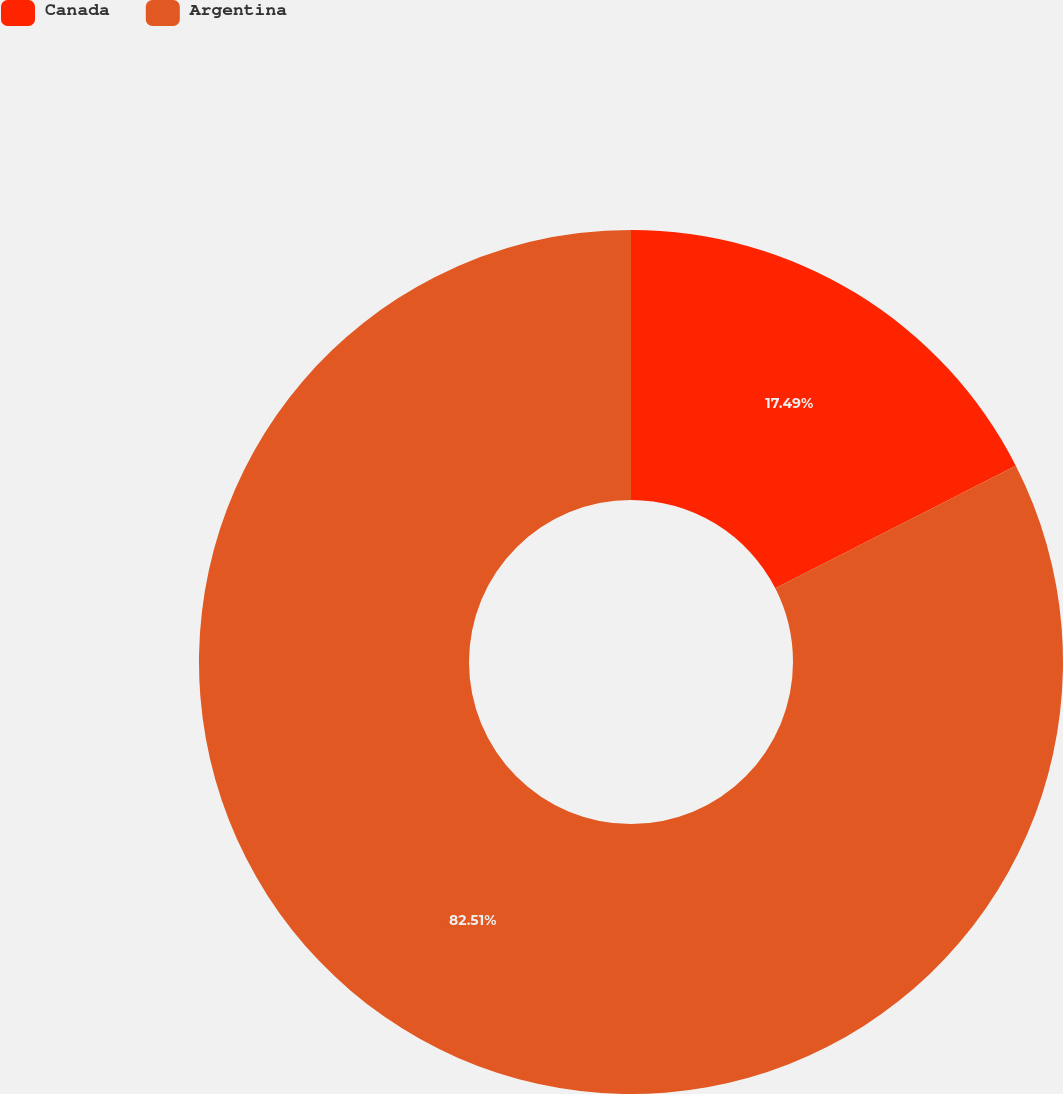<chart> <loc_0><loc_0><loc_500><loc_500><pie_chart><fcel>Canada<fcel>Argentina<nl><fcel>17.49%<fcel>82.51%<nl></chart> 